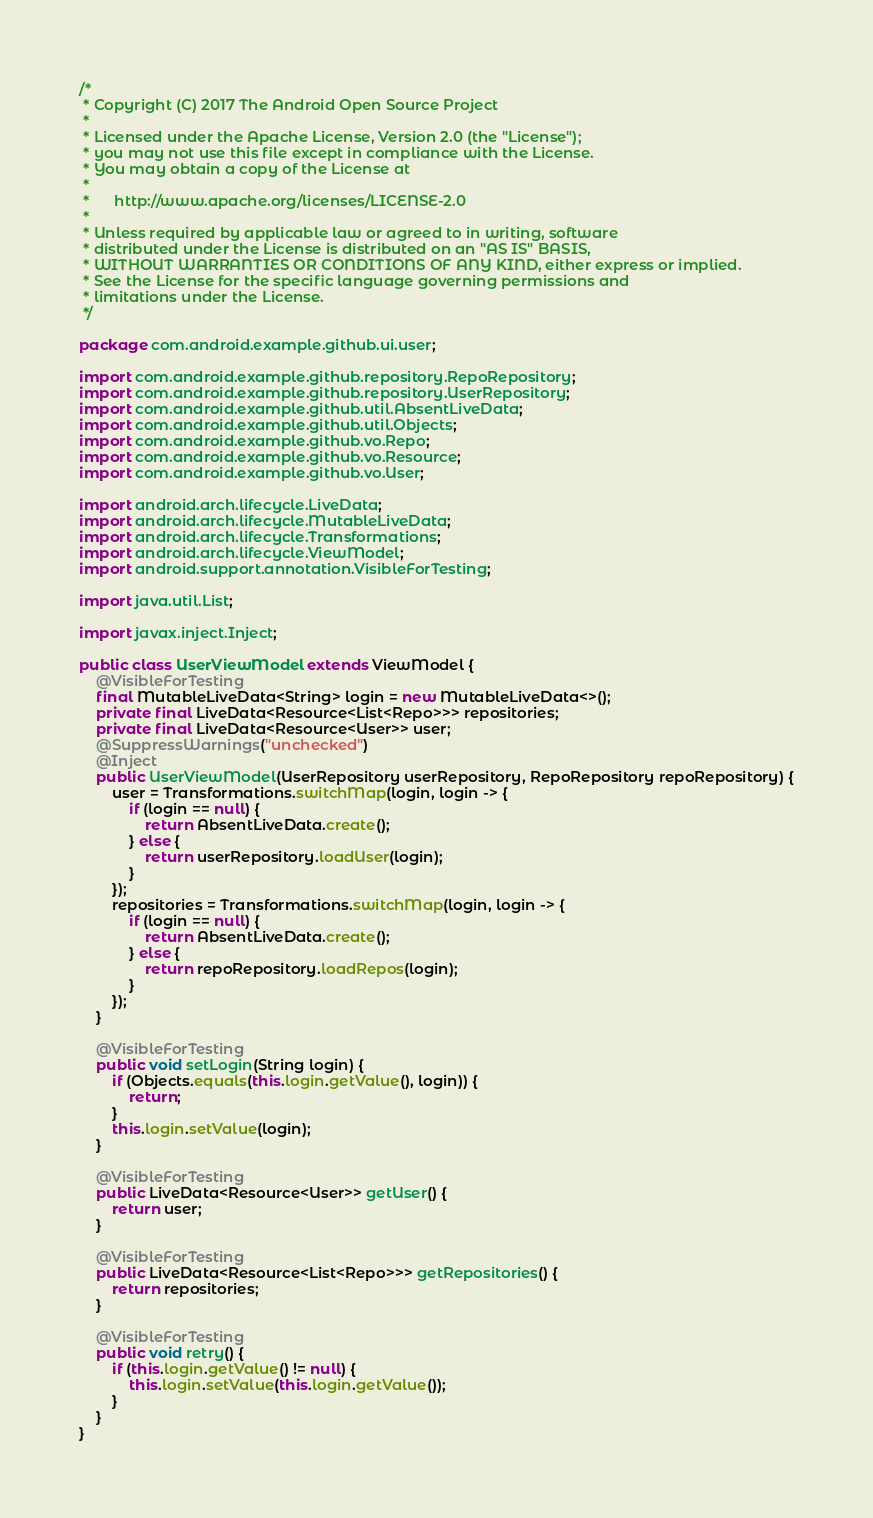Convert code to text. <code><loc_0><loc_0><loc_500><loc_500><_Java_>/*
 * Copyright (C) 2017 The Android Open Source Project
 *
 * Licensed under the Apache License, Version 2.0 (the "License");
 * you may not use this file except in compliance with the License.
 * You may obtain a copy of the License at
 *
 *      http://www.apache.org/licenses/LICENSE-2.0
 *
 * Unless required by applicable law or agreed to in writing, software
 * distributed under the License is distributed on an "AS IS" BASIS,
 * WITHOUT WARRANTIES OR CONDITIONS OF ANY KIND, either express or implied.
 * See the License for the specific language governing permissions and
 * limitations under the License.
 */

package com.android.example.github.ui.user;

import com.android.example.github.repository.RepoRepository;
import com.android.example.github.repository.UserRepository;
import com.android.example.github.util.AbsentLiveData;
import com.android.example.github.util.Objects;
import com.android.example.github.vo.Repo;
import com.android.example.github.vo.Resource;
import com.android.example.github.vo.User;

import android.arch.lifecycle.LiveData;
import android.arch.lifecycle.MutableLiveData;
import android.arch.lifecycle.Transformations;
import android.arch.lifecycle.ViewModel;
import android.support.annotation.VisibleForTesting;

import java.util.List;

import javax.inject.Inject;

public class UserViewModel extends ViewModel {
    @VisibleForTesting
    final MutableLiveData<String> login = new MutableLiveData<>();
    private final LiveData<Resource<List<Repo>>> repositories;
    private final LiveData<Resource<User>> user;
    @SuppressWarnings("unchecked")
    @Inject
    public UserViewModel(UserRepository userRepository, RepoRepository repoRepository) {
        user = Transformations.switchMap(login, login -> {
            if (login == null) {
                return AbsentLiveData.create();
            } else {
                return userRepository.loadUser(login);
            }
        });
        repositories = Transformations.switchMap(login, login -> {
            if (login == null) {
                return AbsentLiveData.create();
            } else {
                return repoRepository.loadRepos(login);
            }
        });
    }

    @VisibleForTesting
    public void setLogin(String login) {
        if (Objects.equals(this.login.getValue(), login)) {
            return;
        }
        this.login.setValue(login);
    }

    @VisibleForTesting
    public LiveData<Resource<User>> getUser() {
        return user;
    }

    @VisibleForTesting
    public LiveData<Resource<List<Repo>>> getRepositories() {
        return repositories;
    }

    @VisibleForTesting
    public void retry() {
        if (this.login.getValue() != null) {
            this.login.setValue(this.login.getValue());
        }
    }
}
</code> 